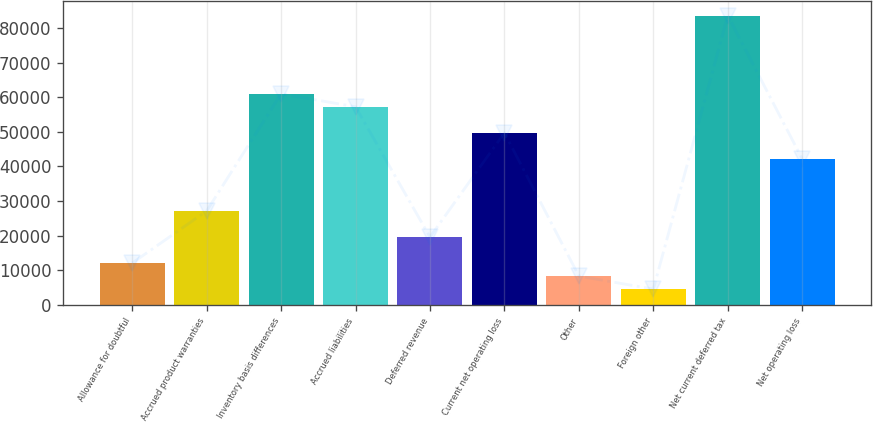Convert chart. <chart><loc_0><loc_0><loc_500><loc_500><bar_chart><fcel>Allowance for doubtful<fcel>Accrued product warranties<fcel>Inventory basis differences<fcel>Accrued liabilities<fcel>Deferred revenue<fcel>Current net operating loss<fcel>Other<fcel>Foreign other<fcel>Net current deferred tax<fcel>Net operating loss<nl><fcel>12048.7<fcel>27100.3<fcel>60966.4<fcel>57203.5<fcel>19574.5<fcel>49677.7<fcel>8285.8<fcel>4522.9<fcel>83543.8<fcel>42151.9<nl></chart> 